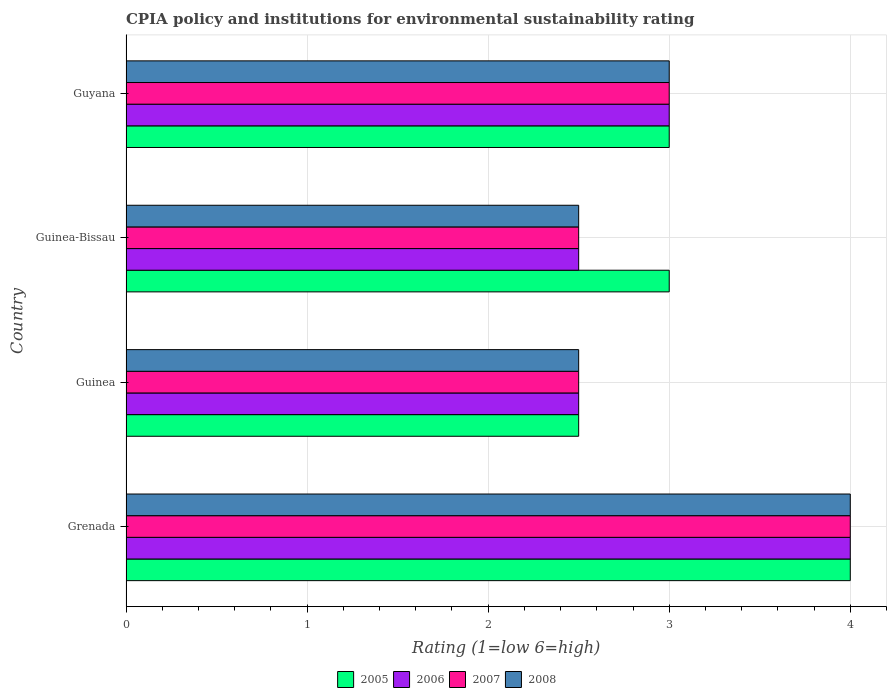Are the number of bars on each tick of the Y-axis equal?
Ensure brevity in your answer.  Yes. How many bars are there on the 3rd tick from the top?
Keep it short and to the point. 4. How many bars are there on the 1st tick from the bottom?
Make the answer very short. 4. What is the label of the 3rd group of bars from the top?
Give a very brief answer. Guinea. In how many cases, is the number of bars for a given country not equal to the number of legend labels?
Provide a short and direct response. 0. What is the CPIA rating in 2007 in Guinea?
Keep it short and to the point. 2.5. Across all countries, what is the minimum CPIA rating in 2007?
Your answer should be compact. 2.5. In which country was the CPIA rating in 2007 maximum?
Ensure brevity in your answer.  Grenada. In which country was the CPIA rating in 2008 minimum?
Offer a terse response. Guinea. What is the difference between the CPIA rating in 2006 in Grenada and that in Guinea?
Your answer should be very brief. 1.5. What is the difference between the CPIA rating in 2005 in Guyana and the CPIA rating in 2007 in Guinea?
Your answer should be very brief. 0.5. What is the average CPIA rating in 2006 per country?
Give a very brief answer. 3. What is the difference between the CPIA rating in 2005 and CPIA rating in 2008 in Guinea-Bissau?
Give a very brief answer. 0.5. In how many countries, is the CPIA rating in 2007 greater than 0.4 ?
Give a very brief answer. 4. What is the ratio of the CPIA rating in 2007 in Guinea to that in Guyana?
Keep it short and to the point. 0.83. Is the CPIA rating in 2005 in Guinea less than that in Guinea-Bissau?
Provide a succinct answer. Yes. What is the difference between the highest and the second highest CPIA rating in 2006?
Make the answer very short. 1. In how many countries, is the CPIA rating in 2007 greater than the average CPIA rating in 2007 taken over all countries?
Ensure brevity in your answer.  1. Is it the case that in every country, the sum of the CPIA rating in 2005 and CPIA rating in 2006 is greater than the sum of CPIA rating in 2007 and CPIA rating in 2008?
Keep it short and to the point. No. Is it the case that in every country, the sum of the CPIA rating in 2007 and CPIA rating in 2006 is greater than the CPIA rating in 2005?
Keep it short and to the point. Yes. Are all the bars in the graph horizontal?
Give a very brief answer. Yes. How many countries are there in the graph?
Give a very brief answer. 4. What is the difference between two consecutive major ticks on the X-axis?
Ensure brevity in your answer.  1. Does the graph contain grids?
Your response must be concise. Yes. Where does the legend appear in the graph?
Offer a very short reply. Bottom center. How are the legend labels stacked?
Keep it short and to the point. Horizontal. What is the title of the graph?
Keep it short and to the point. CPIA policy and institutions for environmental sustainability rating. Does "1979" appear as one of the legend labels in the graph?
Make the answer very short. No. What is the Rating (1=low 6=high) of 2006 in Grenada?
Offer a terse response. 4. What is the Rating (1=low 6=high) in 2007 in Grenada?
Make the answer very short. 4. What is the Rating (1=low 6=high) in 2008 in Grenada?
Your answer should be compact. 4. What is the Rating (1=low 6=high) in 2006 in Guinea?
Make the answer very short. 2.5. What is the Rating (1=low 6=high) of 2007 in Guinea?
Provide a succinct answer. 2.5. What is the Rating (1=low 6=high) of 2008 in Guinea?
Your answer should be very brief. 2.5. What is the Rating (1=low 6=high) of 2005 in Guinea-Bissau?
Your answer should be compact. 3. What is the Rating (1=low 6=high) in 2006 in Guinea-Bissau?
Keep it short and to the point. 2.5. What is the Rating (1=low 6=high) of 2008 in Guinea-Bissau?
Offer a very short reply. 2.5. What is the Rating (1=low 6=high) of 2005 in Guyana?
Your answer should be very brief. 3. What is the Rating (1=low 6=high) in 2007 in Guyana?
Provide a succinct answer. 3. What is the Rating (1=low 6=high) in 2008 in Guyana?
Keep it short and to the point. 3. Across all countries, what is the maximum Rating (1=low 6=high) in 2006?
Keep it short and to the point. 4. Across all countries, what is the maximum Rating (1=low 6=high) in 2007?
Ensure brevity in your answer.  4. Across all countries, what is the minimum Rating (1=low 6=high) of 2005?
Make the answer very short. 2.5. Across all countries, what is the minimum Rating (1=low 6=high) of 2006?
Ensure brevity in your answer.  2.5. Across all countries, what is the minimum Rating (1=low 6=high) of 2008?
Make the answer very short. 2.5. What is the total Rating (1=low 6=high) of 2005 in the graph?
Your response must be concise. 12.5. What is the total Rating (1=low 6=high) in 2006 in the graph?
Offer a terse response. 12. What is the total Rating (1=low 6=high) in 2008 in the graph?
Make the answer very short. 12. What is the difference between the Rating (1=low 6=high) of 2007 in Grenada and that in Guinea?
Offer a very short reply. 1.5. What is the difference between the Rating (1=low 6=high) of 2008 in Grenada and that in Guinea?
Keep it short and to the point. 1.5. What is the difference between the Rating (1=low 6=high) in 2006 in Grenada and that in Guinea-Bissau?
Provide a succinct answer. 1.5. What is the difference between the Rating (1=low 6=high) in 2008 in Grenada and that in Guinea-Bissau?
Give a very brief answer. 1.5. What is the difference between the Rating (1=low 6=high) in 2006 in Grenada and that in Guyana?
Give a very brief answer. 1. What is the difference between the Rating (1=low 6=high) in 2005 in Guinea and that in Guinea-Bissau?
Offer a very short reply. -0.5. What is the difference between the Rating (1=low 6=high) of 2006 in Guinea and that in Guinea-Bissau?
Your answer should be compact. 0. What is the difference between the Rating (1=low 6=high) of 2007 in Guinea and that in Guinea-Bissau?
Keep it short and to the point. 0. What is the difference between the Rating (1=low 6=high) of 2005 in Guinea and that in Guyana?
Keep it short and to the point. -0.5. What is the difference between the Rating (1=low 6=high) of 2006 in Guinea and that in Guyana?
Offer a terse response. -0.5. What is the difference between the Rating (1=low 6=high) of 2005 in Guinea-Bissau and that in Guyana?
Make the answer very short. 0. What is the difference between the Rating (1=low 6=high) in 2008 in Guinea-Bissau and that in Guyana?
Your answer should be compact. -0.5. What is the difference between the Rating (1=low 6=high) in 2005 in Grenada and the Rating (1=low 6=high) in 2006 in Guinea?
Provide a succinct answer. 1.5. What is the difference between the Rating (1=low 6=high) in 2005 in Grenada and the Rating (1=low 6=high) in 2008 in Guinea?
Give a very brief answer. 1.5. What is the difference between the Rating (1=low 6=high) in 2005 in Grenada and the Rating (1=low 6=high) in 2008 in Guinea-Bissau?
Provide a succinct answer. 1.5. What is the difference between the Rating (1=low 6=high) in 2006 in Grenada and the Rating (1=low 6=high) in 2007 in Guinea-Bissau?
Provide a short and direct response. 1.5. What is the difference between the Rating (1=low 6=high) of 2006 in Grenada and the Rating (1=low 6=high) of 2008 in Guinea-Bissau?
Ensure brevity in your answer.  1.5. What is the difference between the Rating (1=low 6=high) of 2007 in Grenada and the Rating (1=low 6=high) of 2008 in Guinea-Bissau?
Your response must be concise. 1.5. What is the difference between the Rating (1=low 6=high) in 2005 in Grenada and the Rating (1=low 6=high) in 2007 in Guyana?
Provide a short and direct response. 1. What is the difference between the Rating (1=low 6=high) in 2007 in Grenada and the Rating (1=low 6=high) in 2008 in Guyana?
Give a very brief answer. 1. What is the difference between the Rating (1=low 6=high) in 2005 in Guinea and the Rating (1=low 6=high) in 2006 in Guinea-Bissau?
Provide a short and direct response. 0. What is the difference between the Rating (1=low 6=high) of 2006 in Guinea and the Rating (1=low 6=high) of 2008 in Guinea-Bissau?
Ensure brevity in your answer.  0. What is the difference between the Rating (1=low 6=high) of 2005 in Guinea and the Rating (1=low 6=high) of 2006 in Guyana?
Your response must be concise. -0.5. What is the difference between the Rating (1=low 6=high) of 2005 in Guinea and the Rating (1=low 6=high) of 2007 in Guyana?
Provide a short and direct response. -0.5. What is the difference between the Rating (1=low 6=high) of 2005 in Guinea and the Rating (1=low 6=high) of 2008 in Guyana?
Make the answer very short. -0.5. What is the difference between the Rating (1=low 6=high) of 2005 in Guinea-Bissau and the Rating (1=low 6=high) of 2006 in Guyana?
Your answer should be compact. 0. What is the difference between the Rating (1=low 6=high) in 2005 in Guinea-Bissau and the Rating (1=low 6=high) in 2007 in Guyana?
Provide a short and direct response. 0. What is the difference between the Rating (1=low 6=high) of 2005 in Guinea-Bissau and the Rating (1=low 6=high) of 2008 in Guyana?
Offer a terse response. 0. What is the difference between the Rating (1=low 6=high) of 2006 in Guinea-Bissau and the Rating (1=low 6=high) of 2007 in Guyana?
Your response must be concise. -0.5. What is the difference between the Rating (1=low 6=high) in 2006 in Guinea-Bissau and the Rating (1=low 6=high) in 2008 in Guyana?
Make the answer very short. -0.5. What is the difference between the Rating (1=low 6=high) of 2007 in Guinea-Bissau and the Rating (1=low 6=high) of 2008 in Guyana?
Provide a short and direct response. -0.5. What is the average Rating (1=low 6=high) in 2005 per country?
Your answer should be compact. 3.12. What is the average Rating (1=low 6=high) of 2007 per country?
Make the answer very short. 3. What is the difference between the Rating (1=low 6=high) in 2005 and Rating (1=low 6=high) in 2006 in Grenada?
Make the answer very short. 0. What is the difference between the Rating (1=low 6=high) of 2005 and Rating (1=low 6=high) of 2007 in Grenada?
Your answer should be compact. 0. What is the difference between the Rating (1=low 6=high) in 2006 and Rating (1=low 6=high) in 2008 in Grenada?
Give a very brief answer. 0. What is the difference between the Rating (1=low 6=high) in 2007 and Rating (1=low 6=high) in 2008 in Grenada?
Give a very brief answer. 0. What is the difference between the Rating (1=low 6=high) of 2005 and Rating (1=low 6=high) of 2008 in Guinea?
Keep it short and to the point. 0. What is the difference between the Rating (1=low 6=high) in 2007 and Rating (1=low 6=high) in 2008 in Guinea?
Make the answer very short. 0. What is the difference between the Rating (1=low 6=high) of 2005 and Rating (1=low 6=high) of 2006 in Guinea-Bissau?
Your answer should be compact. 0.5. What is the difference between the Rating (1=low 6=high) in 2005 and Rating (1=low 6=high) in 2007 in Guinea-Bissau?
Offer a very short reply. 0.5. What is the difference between the Rating (1=low 6=high) of 2005 and Rating (1=low 6=high) of 2008 in Guinea-Bissau?
Offer a very short reply. 0.5. What is the difference between the Rating (1=low 6=high) of 2006 and Rating (1=low 6=high) of 2007 in Guinea-Bissau?
Your answer should be compact. 0. What is the difference between the Rating (1=low 6=high) in 2006 and Rating (1=low 6=high) in 2008 in Guinea-Bissau?
Make the answer very short. 0. What is the difference between the Rating (1=low 6=high) of 2007 and Rating (1=low 6=high) of 2008 in Guinea-Bissau?
Give a very brief answer. 0. What is the difference between the Rating (1=low 6=high) of 2005 and Rating (1=low 6=high) of 2006 in Guyana?
Provide a succinct answer. 0. What is the difference between the Rating (1=low 6=high) in 2006 and Rating (1=low 6=high) in 2008 in Guyana?
Your answer should be compact. 0. What is the difference between the Rating (1=low 6=high) in 2007 and Rating (1=low 6=high) in 2008 in Guyana?
Offer a terse response. 0. What is the ratio of the Rating (1=low 6=high) in 2006 in Grenada to that in Guinea?
Your answer should be compact. 1.6. What is the ratio of the Rating (1=low 6=high) in 2008 in Grenada to that in Guinea?
Your response must be concise. 1.6. What is the ratio of the Rating (1=low 6=high) of 2005 in Grenada to that in Guinea-Bissau?
Give a very brief answer. 1.33. What is the ratio of the Rating (1=low 6=high) in 2006 in Grenada to that in Guinea-Bissau?
Your answer should be very brief. 1.6. What is the ratio of the Rating (1=low 6=high) in 2007 in Grenada to that in Guinea-Bissau?
Offer a terse response. 1.6. What is the ratio of the Rating (1=low 6=high) in 2006 in Grenada to that in Guyana?
Your answer should be compact. 1.33. What is the ratio of the Rating (1=low 6=high) of 2007 in Guinea to that in Guinea-Bissau?
Your answer should be compact. 1. What is the ratio of the Rating (1=low 6=high) of 2008 in Guinea to that in Guinea-Bissau?
Give a very brief answer. 1. What is the ratio of the Rating (1=low 6=high) of 2005 in Guinea to that in Guyana?
Ensure brevity in your answer.  0.83. What is the ratio of the Rating (1=low 6=high) in 2006 in Guinea to that in Guyana?
Offer a terse response. 0.83. What is the ratio of the Rating (1=low 6=high) in 2007 in Guinea to that in Guyana?
Give a very brief answer. 0.83. What is the ratio of the Rating (1=low 6=high) of 2008 in Guinea to that in Guyana?
Ensure brevity in your answer.  0.83. What is the ratio of the Rating (1=low 6=high) of 2008 in Guinea-Bissau to that in Guyana?
Keep it short and to the point. 0.83. What is the difference between the highest and the second highest Rating (1=low 6=high) in 2006?
Give a very brief answer. 1. What is the difference between the highest and the second highest Rating (1=low 6=high) of 2008?
Give a very brief answer. 1. What is the difference between the highest and the lowest Rating (1=low 6=high) in 2005?
Your response must be concise. 1.5. 